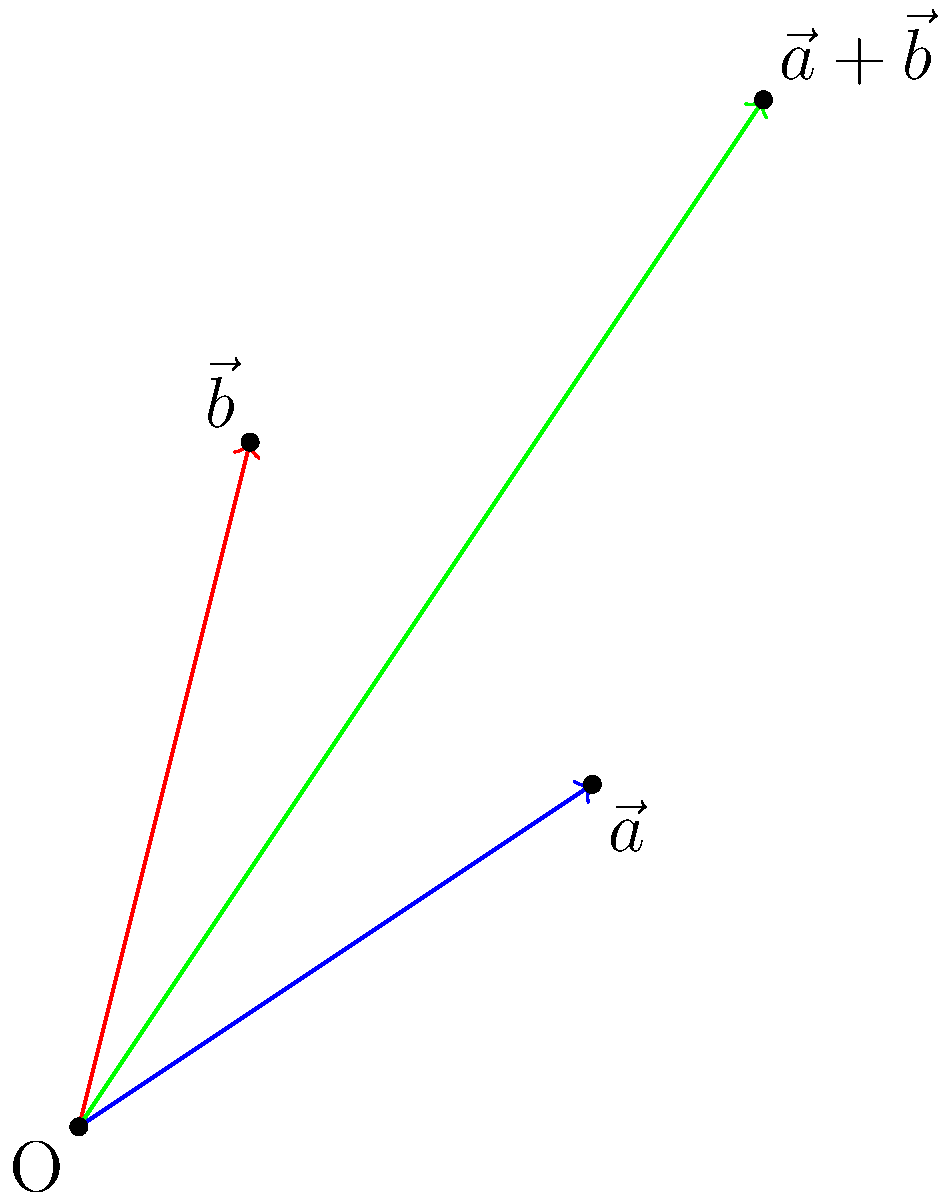As a software engineer preparing for a presentation, you need to explain vector addition to your team. Given two vectors $\vec{a} = (3, 2)$ and $\vec{b} = (1, 4)$, calculate the resultant vector $\vec{r} = \vec{a} + \vec{b}$. What are the components of the resultant vector? To calculate the resultant vector when adding two vectors, we follow these steps:

1. Identify the components of each vector:
   $\vec{a} = (3, 2)$ and $\vec{b} = (1, 4)$

2. Add the corresponding components:
   - x-component: $3 + 1 = 4$
   - y-component: $2 + 4 = 6$

3. Express the resultant vector:
   $\vec{r} = \vec{a} + \vec{b} = (4, 6)$

Geometrically, this can be visualized as the diagonal of the parallelogram formed by the two vectors, as shown in the diagram. The green arrow represents the resultant vector $\vec{r}$, which starts at the origin and ends at the point (4, 6).

This method of adding vectors is called the parallelogram method or the tip-to-tail method. It works because vector addition is commutative, meaning $\vec{a} + \vec{b} = \vec{b} + \vec{a}$.
Answer: $(4, 6)$ 